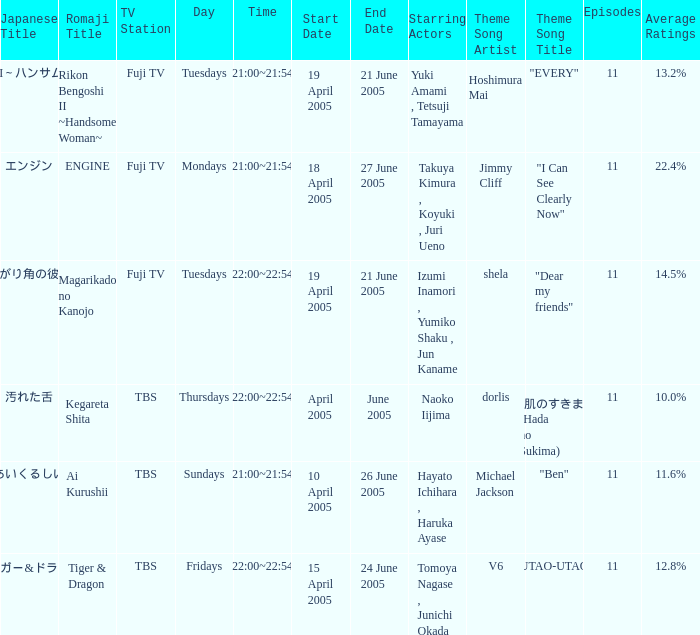Who is the star of the program on Thursdays 22:00~22:54 2005-04-xx to 2005-06-xx? Naoko Iijima. 